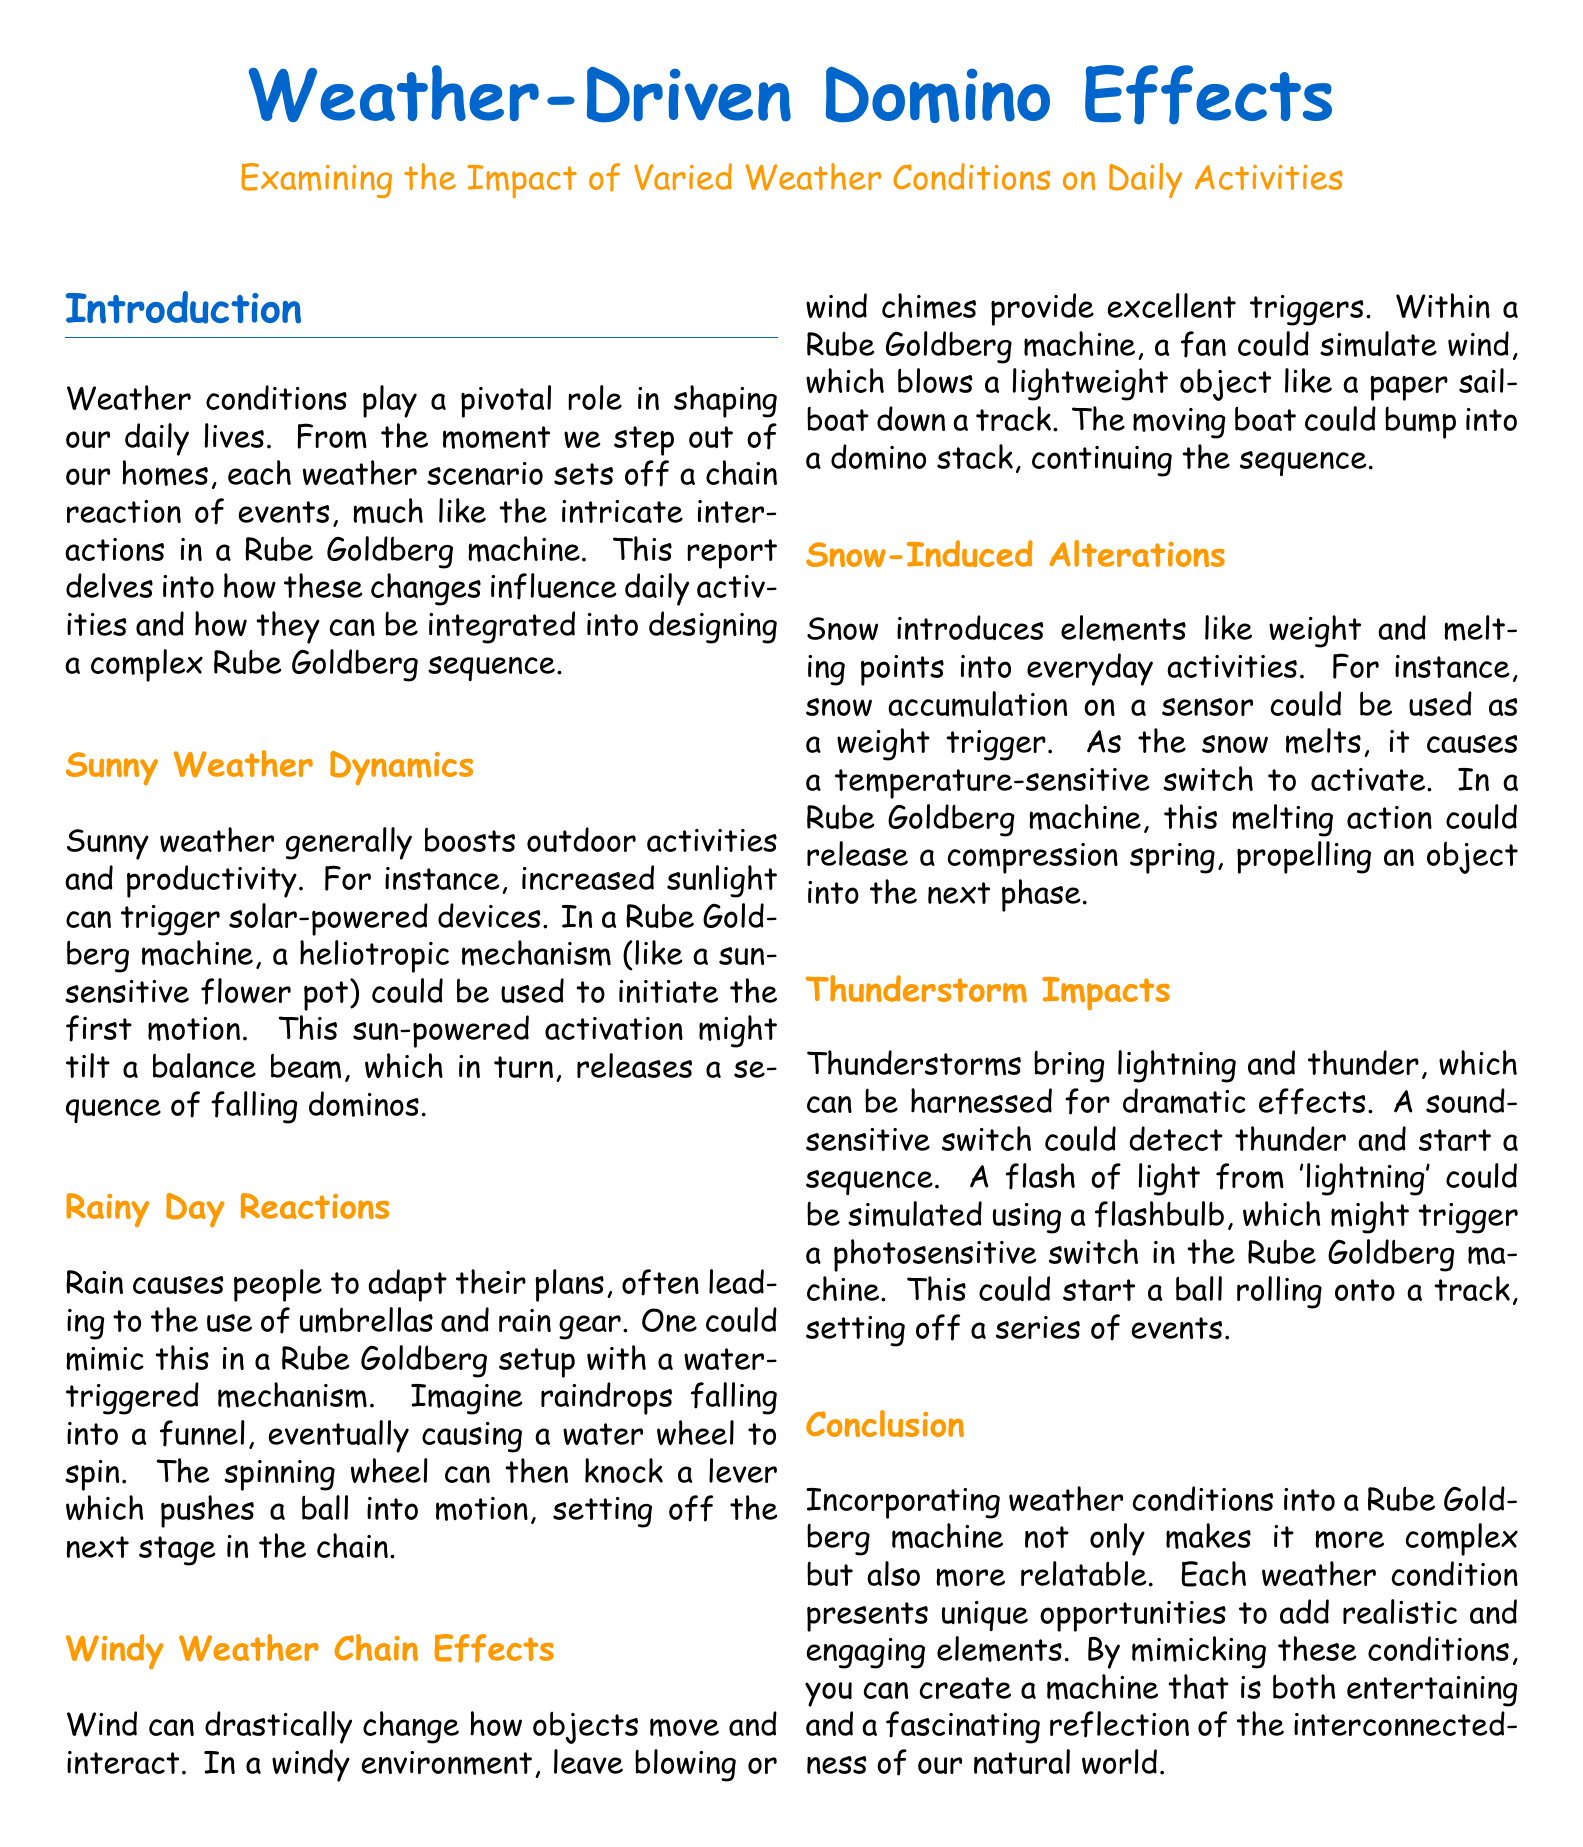What is the title of the report? The title of the report is prominently featured at the top and is "Weather-Driven Domino Effects".
Answer: Weather-Driven Domino Effects What color is used for the section titles? The document uses a defined color for section titles, which is maincolor (RGB(0,102,204)).
Answer: maincolor What mechanism is suggested for sunny weather? The report describes a heliotropic mechanism, specifically something like a sun-sensitive flower pot.
Answer: heliotropic mechanism What weather condition triggers the use of umbrellas? The document mentions rain as the weather condition that causes people to adjust their plans and use umbrellas.
Answer: Rain What is a proposed trigger for the windy weather segment in a Rube Goldberg machine? The report suggests using a fan to simulate wind, blowing a lightweight object down a track.
Answer: fan How does snow influence everyday activities according to the report? The document explains that snow accumulation can be used as a weight trigger in a setup.
Answer: weight trigger What type of switch is activated by thunder during thunderstorms? The document states that a sound-sensitive switch could be utilized to detect thunder and start a sequence.
Answer: sound-sensitive switch What is one of the dramatic effects of thunderstorms mentioned? The report talks about using a flashbulb to simulate lightning, which plays a crucial role in the Rube Goldberg sequence.
Answer: flashbulb What is the main theme of the report? The main theme centers around the impact of varied weather conditions on daily activities and Rube Goldberg machine design.
Answer: weather impact 